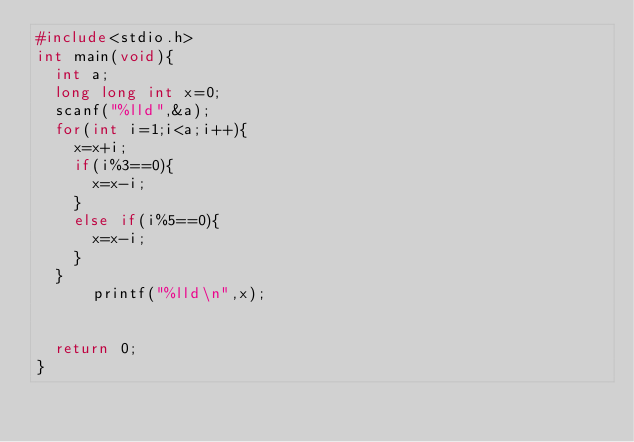Convert code to text. <code><loc_0><loc_0><loc_500><loc_500><_C_>#include<stdio.h>
int main(void){
  int a;
  long long int x=0;
  scanf("%lld",&a);
  for(int i=1;i<a;i++){
    x=x+i;
    if(i%3==0){
      x=x-i;
    }
    else if(i%5==0){
      x=x-i;
    }
  }
      printf("%lld\n",x);
  
  
  return 0;
}</code> 